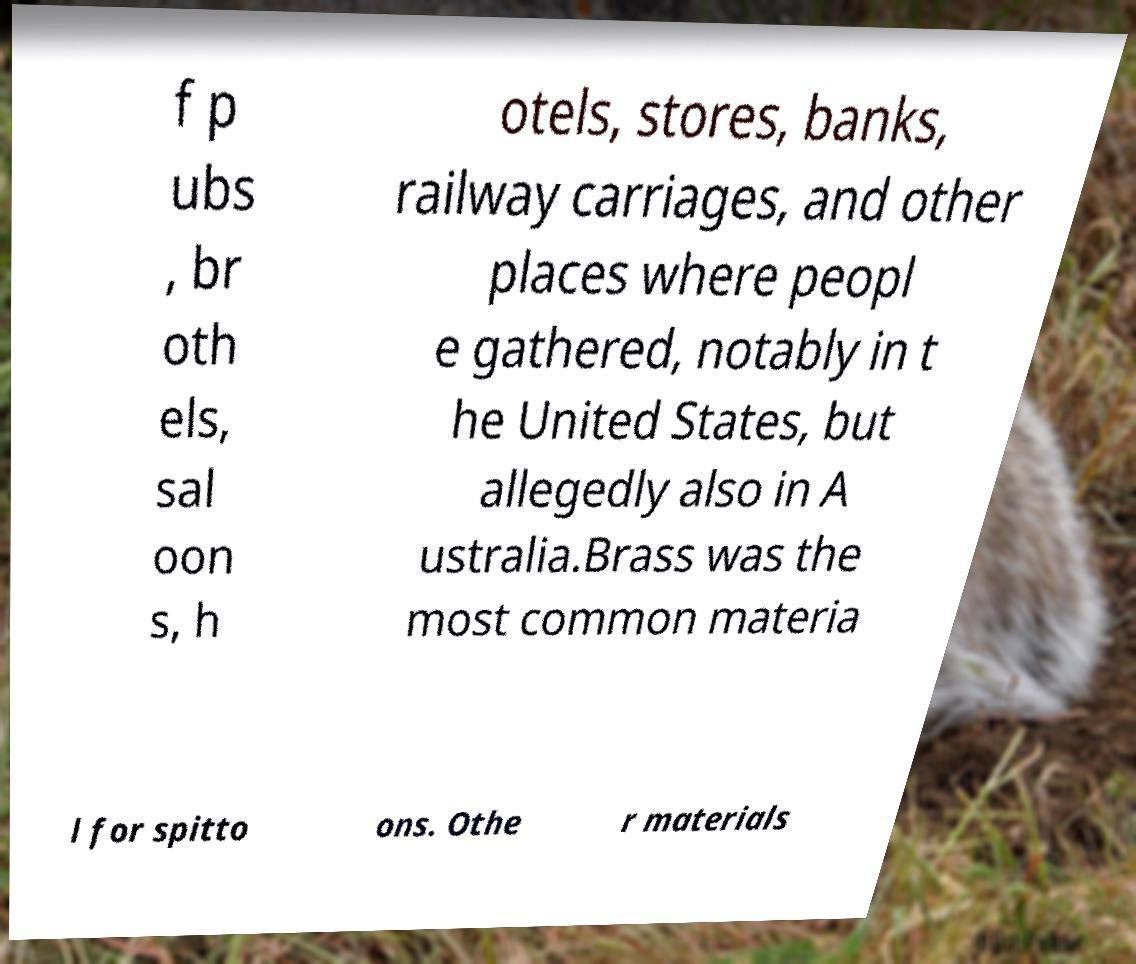Can you read and provide the text displayed in the image?This photo seems to have some interesting text. Can you extract and type it out for me? f p ubs , br oth els, sal oon s, h otels, stores, banks, railway carriages, and other places where peopl e gathered, notably in t he United States, but allegedly also in A ustralia.Brass was the most common materia l for spitto ons. Othe r materials 